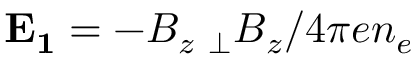Convert formula to latex. <formula><loc_0><loc_0><loc_500><loc_500>E _ { 1 } = - B _ { z } \nabla _ { \bot } B _ { z } / 4 \pi e n _ { e }</formula> 